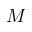Convert formula to latex. <formula><loc_0><loc_0><loc_500><loc_500>M</formula> 